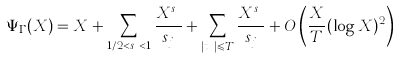<formula> <loc_0><loc_0><loc_500><loc_500>\Psi _ { \Gamma } ( X ) = X + \sum _ { 1 / 2 < s _ { j } < 1 } \frac { X ^ { s _ { j } } } { s _ { j } } + \sum _ { | t _ { j } | \leqslant T } \frac { X ^ { s _ { j } } } { s _ { j } } + O \left ( \frac { X } { T } ( \log X ) ^ { 2 } \right )</formula> 